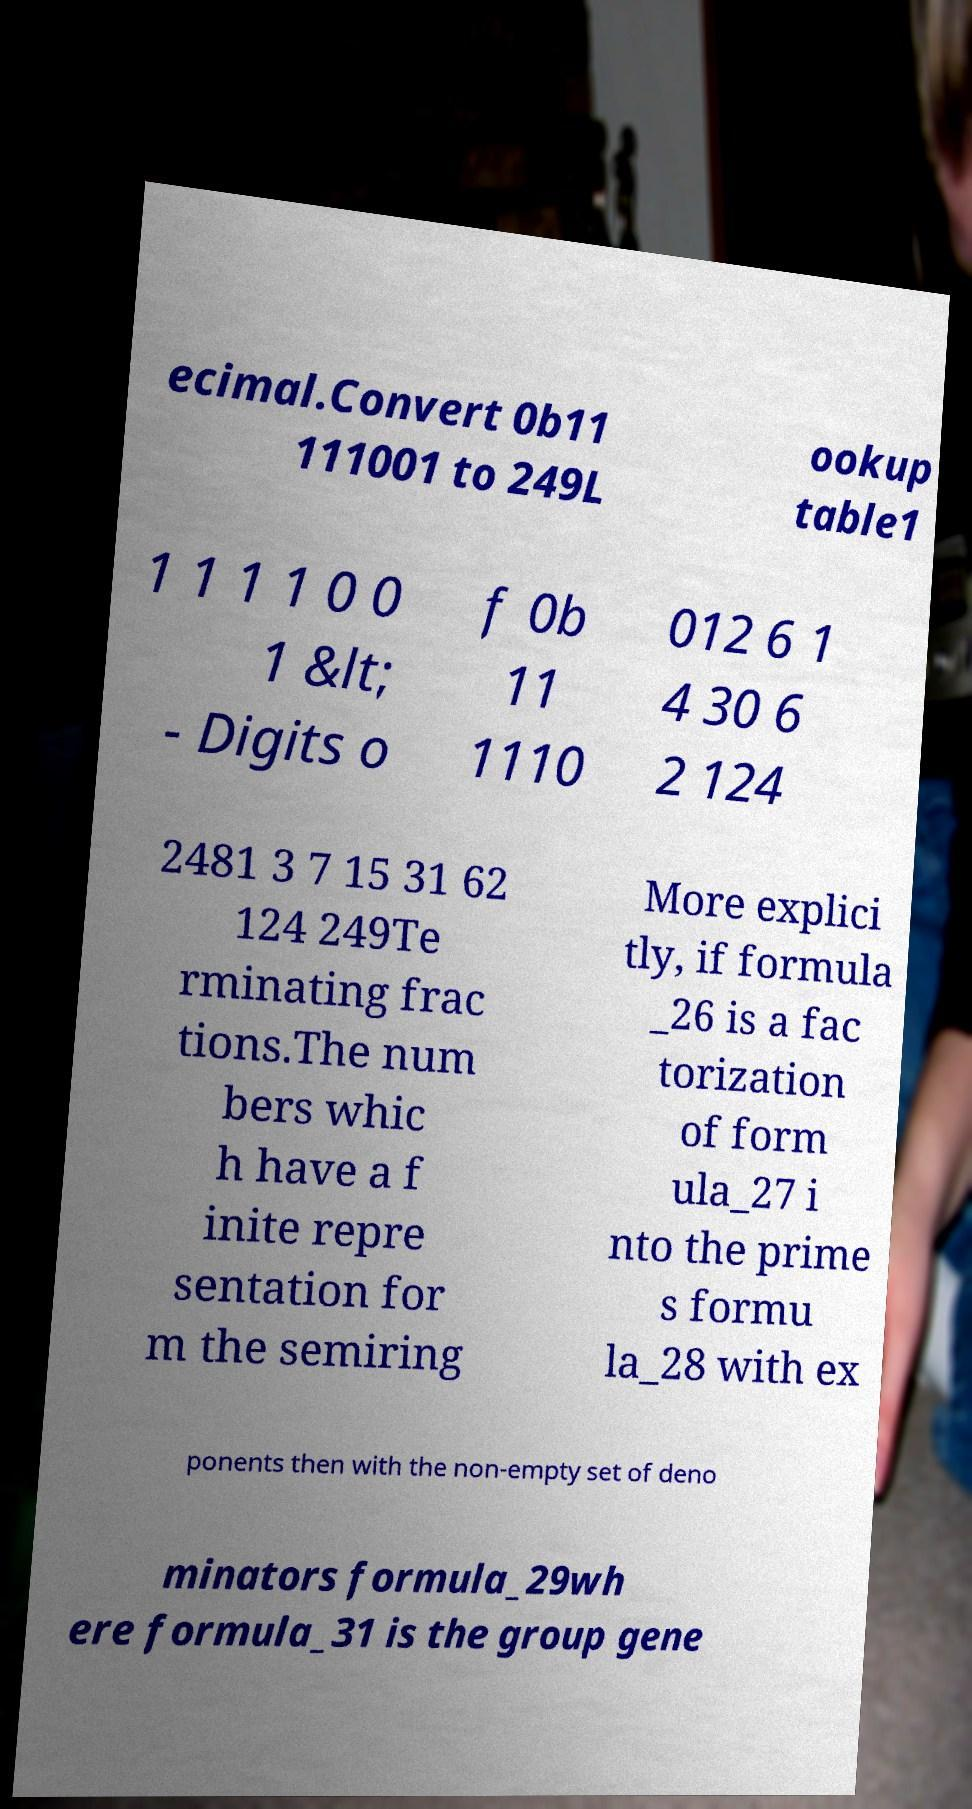Could you extract and type out the text from this image? ecimal.Convert 0b11 111001 to 249L ookup table1 1 1 1 1 0 0 1 &lt; - Digits o f 0b 11 1110 012 6 1 4 30 6 2 124 2481 3 7 15 31 62 124 249Te rminating frac tions.The num bers whic h have a f inite repre sentation for m the semiring More explici tly, if formula _26 is a fac torization of form ula_27 i nto the prime s formu la_28 with ex ponents then with the non-empty set of deno minators formula_29wh ere formula_31 is the group gene 